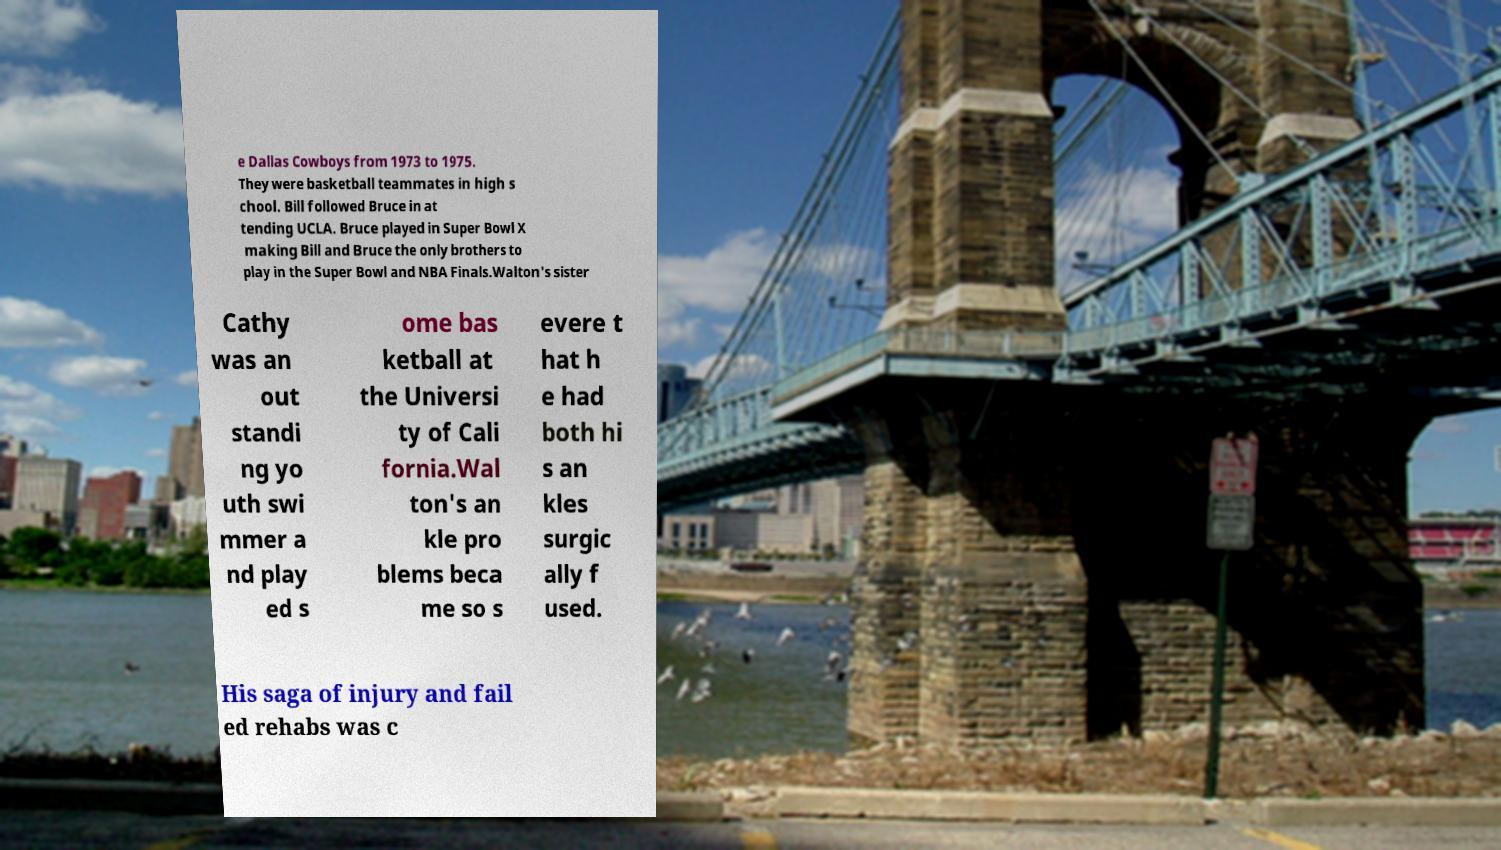Could you extract and type out the text from this image? e Dallas Cowboys from 1973 to 1975. They were basketball teammates in high s chool. Bill followed Bruce in at tending UCLA. Bruce played in Super Bowl X making Bill and Bruce the only brothers to play in the Super Bowl and NBA Finals.Walton's sister Cathy was an out standi ng yo uth swi mmer a nd play ed s ome bas ketball at the Universi ty of Cali fornia.Wal ton's an kle pro blems beca me so s evere t hat h e had both hi s an kles surgic ally f used. His saga of injury and fail ed rehabs was c 